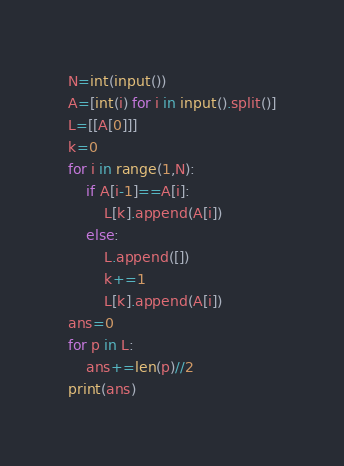<code> <loc_0><loc_0><loc_500><loc_500><_Python_>N=int(input())
A=[int(i) for i in input().split()]
L=[[A[0]]]
k=0
for i in range(1,N):
    if A[i-1]==A[i]:
        L[k].append(A[i])
    else:
        L.append([])
        k+=1
        L[k].append(A[i])
ans=0
for p in L:
    ans+=len(p)//2
print(ans)
</code> 